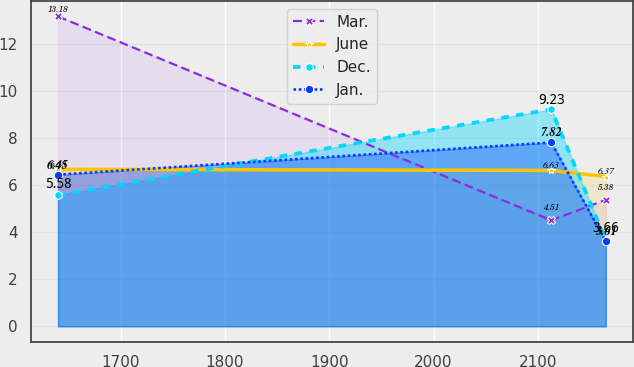<chart> <loc_0><loc_0><loc_500><loc_500><line_chart><ecel><fcel>Mar.<fcel>June<fcel>Dec.<fcel>Jan.<nl><fcel>1639.97<fcel>13.18<fcel>6.68<fcel>5.58<fcel>6.45<nl><fcel>2112.82<fcel>4.51<fcel>6.63<fcel>9.23<fcel>7.82<nl><fcel>2165.11<fcel>5.38<fcel>6.37<fcel>3.66<fcel>3.61<nl></chart> 